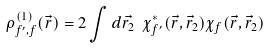<formula> <loc_0><loc_0><loc_500><loc_500>\rho ^ { ( 1 ) } _ { f ^ { \prime } , f } ( \vec { r } ) = 2 \int d \vec { r _ { 2 } } \ \chi _ { f ^ { \prime } } ^ { * } ( \vec { r } , \vec { r } _ { 2 } ) \chi _ { f } ( \vec { r } , \vec { r } _ { 2 } )</formula> 